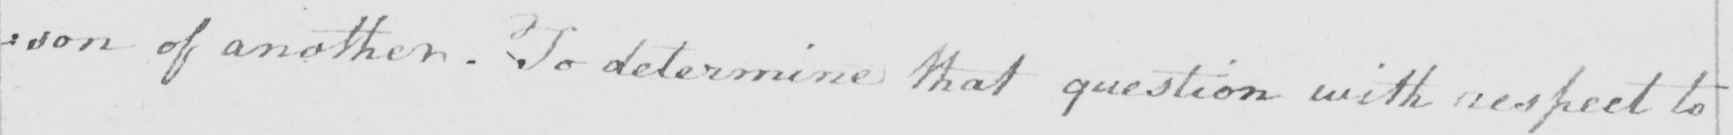What is written in this line of handwriting? : son of another . To determine that question with respect to 